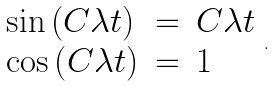<formula> <loc_0><loc_0><loc_500><loc_500>\begin{array} { l c l } \sin \left ( C \lambda t \right ) & = & C \lambda t \\ \cos \left ( C \lambda t \right ) & = & 1 \end{array} .</formula> 